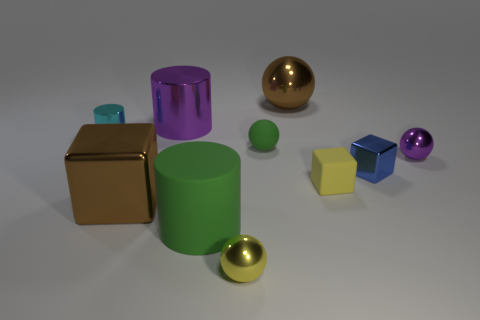What is the shape of the object that is the same color as the rubber cylinder? sphere 